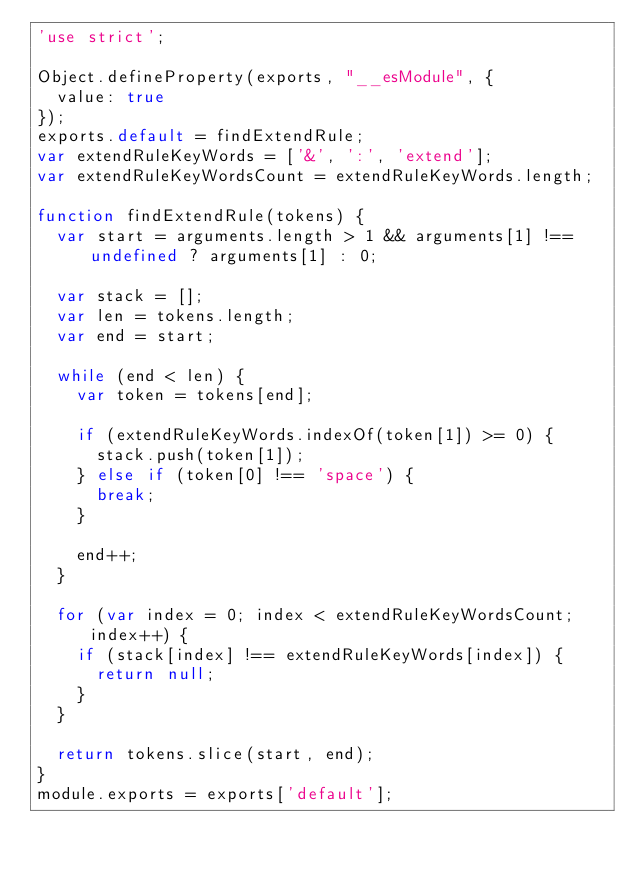<code> <loc_0><loc_0><loc_500><loc_500><_JavaScript_>'use strict';

Object.defineProperty(exports, "__esModule", {
  value: true
});
exports.default = findExtendRule;
var extendRuleKeyWords = ['&', ':', 'extend'];
var extendRuleKeyWordsCount = extendRuleKeyWords.length;

function findExtendRule(tokens) {
  var start = arguments.length > 1 && arguments[1] !== undefined ? arguments[1] : 0;

  var stack = [];
  var len = tokens.length;
  var end = start;

  while (end < len) {
    var token = tokens[end];

    if (extendRuleKeyWords.indexOf(token[1]) >= 0) {
      stack.push(token[1]);
    } else if (token[0] !== 'space') {
      break;
    }

    end++;
  }

  for (var index = 0; index < extendRuleKeyWordsCount; index++) {
    if (stack[index] !== extendRuleKeyWords[index]) {
      return null;
    }
  }

  return tokens.slice(start, end);
}
module.exports = exports['default'];</code> 